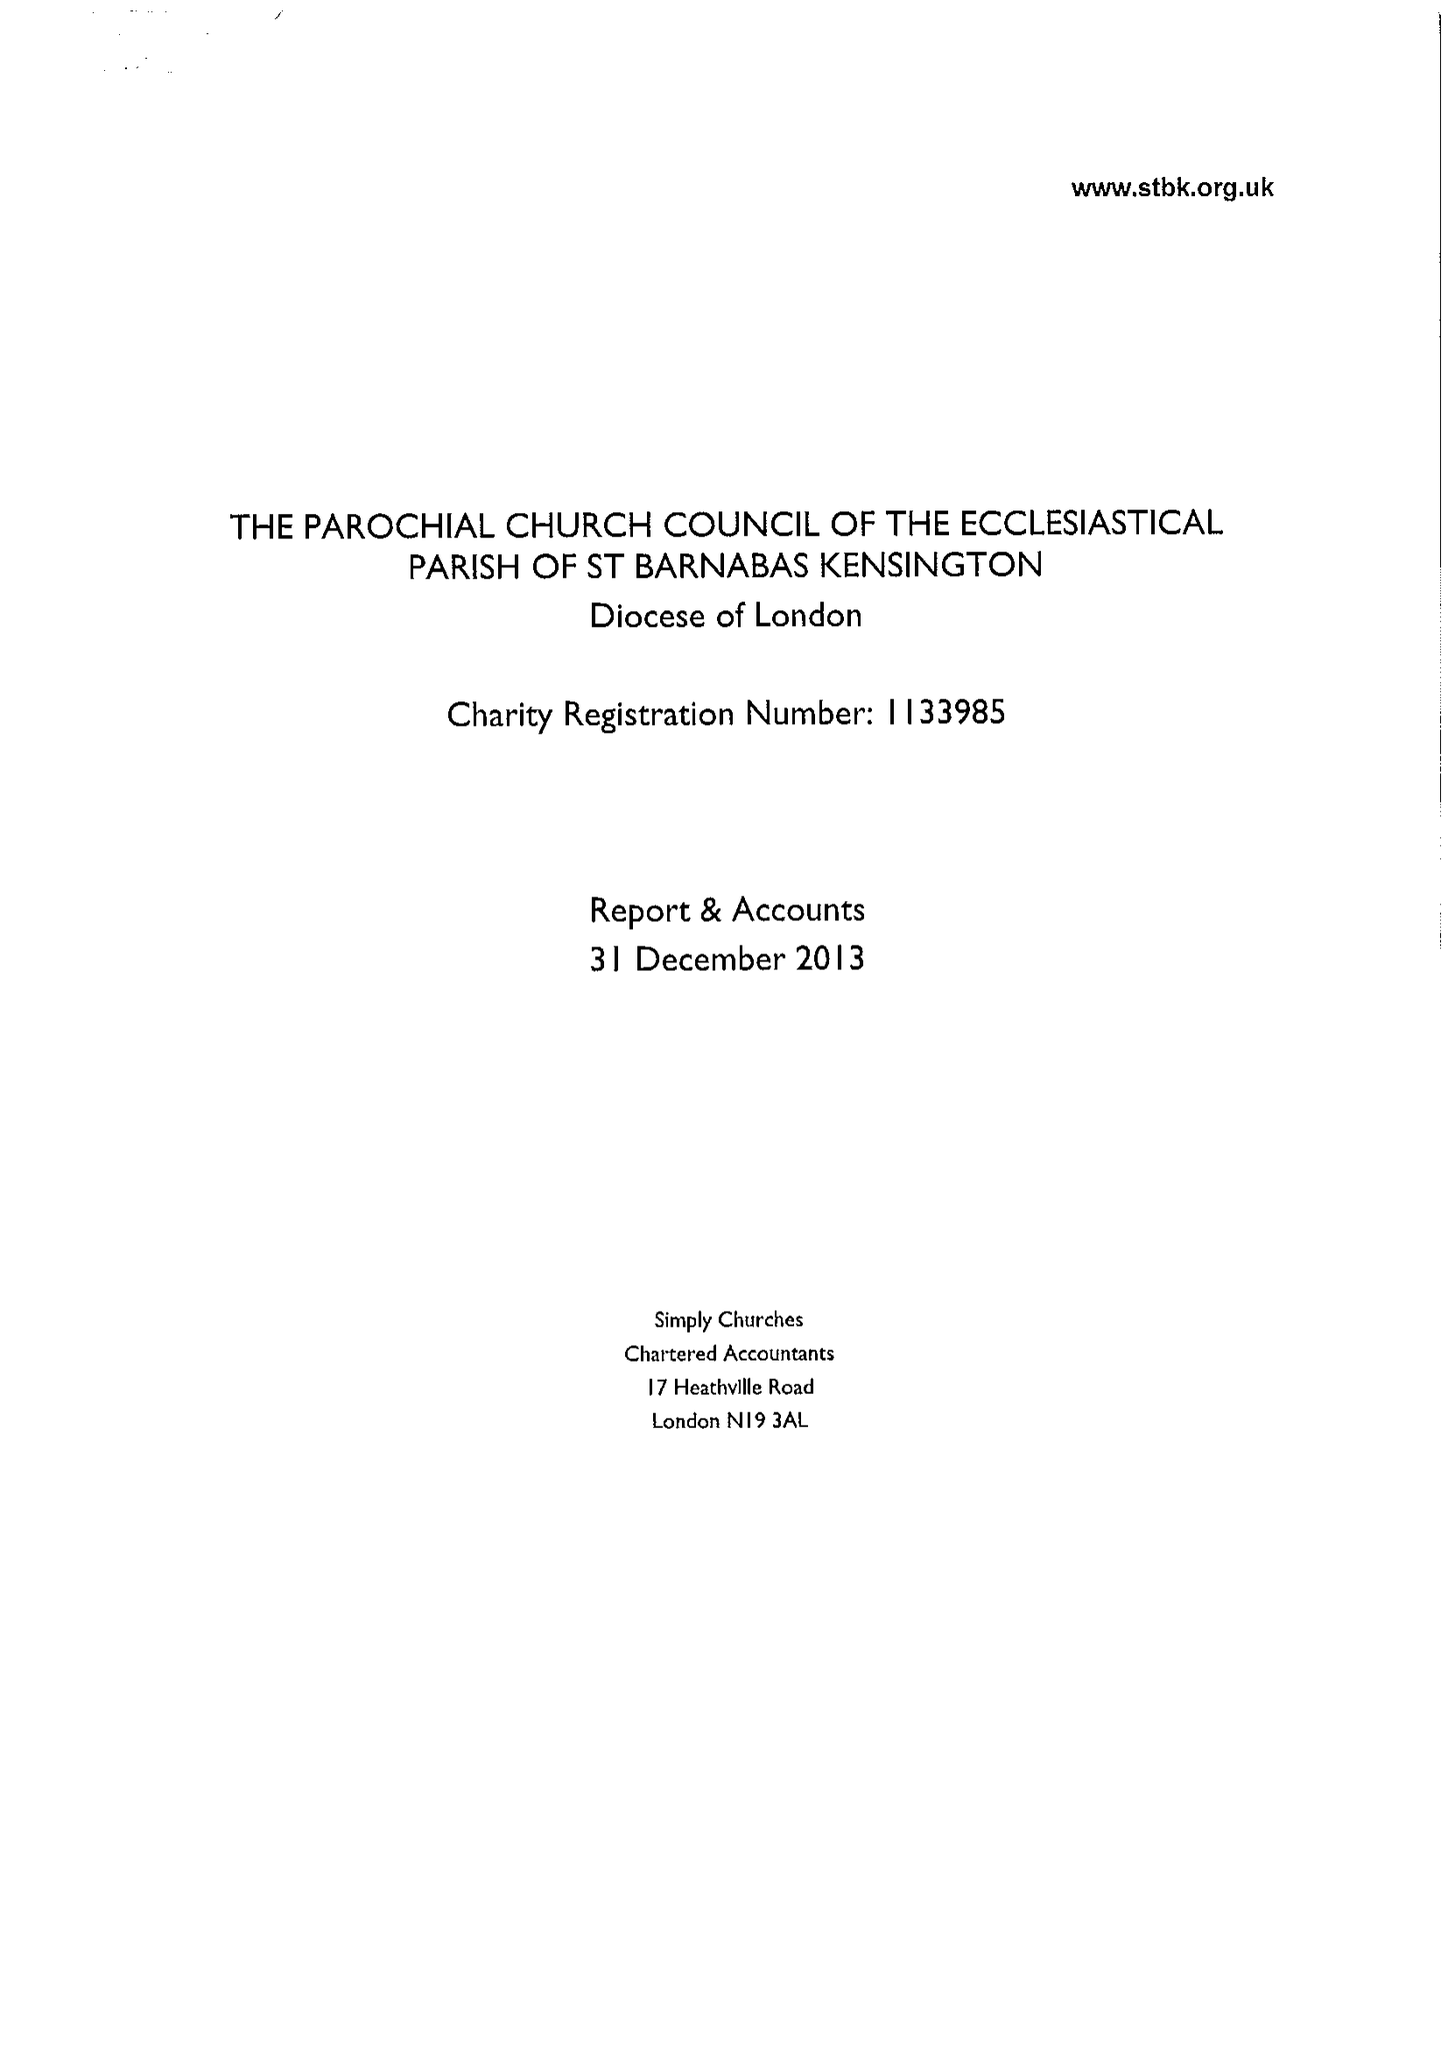What is the value for the address__street_line?
Answer the question using a single word or phrase. 23 ADDISON ROAD 